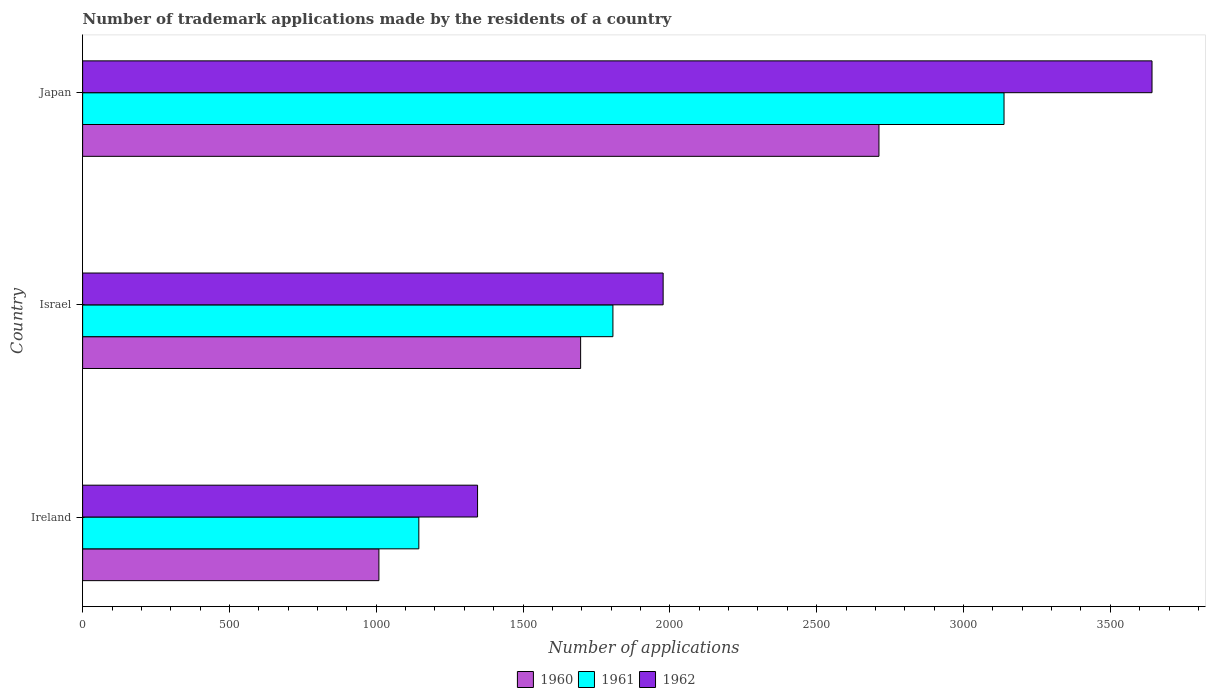How many groups of bars are there?
Offer a very short reply. 3. Are the number of bars on each tick of the Y-axis equal?
Make the answer very short. Yes. What is the label of the 1st group of bars from the top?
Provide a short and direct response. Japan. In how many cases, is the number of bars for a given country not equal to the number of legend labels?
Offer a terse response. 0. What is the number of trademark applications made by the residents in 1961 in Japan?
Make the answer very short. 3138. Across all countries, what is the maximum number of trademark applications made by the residents in 1962?
Offer a terse response. 3642. Across all countries, what is the minimum number of trademark applications made by the residents in 1962?
Give a very brief answer. 1345. In which country was the number of trademark applications made by the residents in 1960 maximum?
Your response must be concise. Japan. In which country was the number of trademark applications made by the residents in 1960 minimum?
Provide a short and direct response. Ireland. What is the total number of trademark applications made by the residents in 1960 in the graph?
Your answer should be very brief. 5417. What is the difference between the number of trademark applications made by the residents in 1960 in Israel and that in Japan?
Make the answer very short. -1016. What is the difference between the number of trademark applications made by the residents in 1961 in Japan and the number of trademark applications made by the residents in 1962 in Ireland?
Offer a very short reply. 1793. What is the average number of trademark applications made by the residents in 1960 per country?
Provide a short and direct response. 1805.67. What is the difference between the number of trademark applications made by the residents in 1962 and number of trademark applications made by the residents in 1961 in Israel?
Your answer should be compact. 171. What is the ratio of the number of trademark applications made by the residents in 1960 in Ireland to that in Israel?
Provide a succinct answer. 0.59. Is the number of trademark applications made by the residents in 1960 in Israel less than that in Japan?
Ensure brevity in your answer.  Yes. What is the difference between the highest and the second highest number of trademark applications made by the residents in 1961?
Your response must be concise. 1332. What is the difference between the highest and the lowest number of trademark applications made by the residents in 1962?
Your answer should be very brief. 2297. Is the sum of the number of trademark applications made by the residents in 1961 in Ireland and Israel greater than the maximum number of trademark applications made by the residents in 1960 across all countries?
Keep it short and to the point. Yes. What does the 2nd bar from the top in Israel represents?
Offer a terse response. 1961. What does the 1st bar from the bottom in Japan represents?
Your response must be concise. 1960. Is it the case that in every country, the sum of the number of trademark applications made by the residents in 1962 and number of trademark applications made by the residents in 1960 is greater than the number of trademark applications made by the residents in 1961?
Provide a short and direct response. Yes. How many bars are there?
Give a very brief answer. 9. How many countries are there in the graph?
Keep it short and to the point. 3. What is the difference between two consecutive major ticks on the X-axis?
Your answer should be compact. 500. Does the graph contain any zero values?
Keep it short and to the point. No. How many legend labels are there?
Your response must be concise. 3. What is the title of the graph?
Offer a terse response. Number of trademark applications made by the residents of a country. Does "1989" appear as one of the legend labels in the graph?
Ensure brevity in your answer.  No. What is the label or title of the X-axis?
Provide a succinct answer. Number of applications. What is the Number of applications of 1960 in Ireland?
Provide a succinct answer. 1009. What is the Number of applications of 1961 in Ireland?
Make the answer very short. 1145. What is the Number of applications in 1962 in Ireland?
Your answer should be compact. 1345. What is the Number of applications of 1960 in Israel?
Offer a terse response. 1696. What is the Number of applications in 1961 in Israel?
Keep it short and to the point. 1806. What is the Number of applications in 1962 in Israel?
Provide a short and direct response. 1977. What is the Number of applications in 1960 in Japan?
Your response must be concise. 2712. What is the Number of applications in 1961 in Japan?
Make the answer very short. 3138. What is the Number of applications of 1962 in Japan?
Make the answer very short. 3642. Across all countries, what is the maximum Number of applications of 1960?
Your answer should be very brief. 2712. Across all countries, what is the maximum Number of applications of 1961?
Offer a terse response. 3138. Across all countries, what is the maximum Number of applications in 1962?
Offer a terse response. 3642. Across all countries, what is the minimum Number of applications in 1960?
Keep it short and to the point. 1009. Across all countries, what is the minimum Number of applications of 1961?
Give a very brief answer. 1145. Across all countries, what is the minimum Number of applications in 1962?
Offer a very short reply. 1345. What is the total Number of applications in 1960 in the graph?
Offer a very short reply. 5417. What is the total Number of applications of 1961 in the graph?
Make the answer very short. 6089. What is the total Number of applications in 1962 in the graph?
Offer a terse response. 6964. What is the difference between the Number of applications of 1960 in Ireland and that in Israel?
Your response must be concise. -687. What is the difference between the Number of applications in 1961 in Ireland and that in Israel?
Your response must be concise. -661. What is the difference between the Number of applications of 1962 in Ireland and that in Israel?
Your answer should be very brief. -632. What is the difference between the Number of applications in 1960 in Ireland and that in Japan?
Offer a very short reply. -1703. What is the difference between the Number of applications in 1961 in Ireland and that in Japan?
Offer a terse response. -1993. What is the difference between the Number of applications of 1962 in Ireland and that in Japan?
Your answer should be compact. -2297. What is the difference between the Number of applications in 1960 in Israel and that in Japan?
Your answer should be very brief. -1016. What is the difference between the Number of applications of 1961 in Israel and that in Japan?
Offer a terse response. -1332. What is the difference between the Number of applications in 1962 in Israel and that in Japan?
Provide a succinct answer. -1665. What is the difference between the Number of applications of 1960 in Ireland and the Number of applications of 1961 in Israel?
Offer a very short reply. -797. What is the difference between the Number of applications in 1960 in Ireland and the Number of applications in 1962 in Israel?
Give a very brief answer. -968. What is the difference between the Number of applications of 1961 in Ireland and the Number of applications of 1962 in Israel?
Ensure brevity in your answer.  -832. What is the difference between the Number of applications in 1960 in Ireland and the Number of applications in 1961 in Japan?
Ensure brevity in your answer.  -2129. What is the difference between the Number of applications of 1960 in Ireland and the Number of applications of 1962 in Japan?
Offer a terse response. -2633. What is the difference between the Number of applications in 1961 in Ireland and the Number of applications in 1962 in Japan?
Provide a succinct answer. -2497. What is the difference between the Number of applications in 1960 in Israel and the Number of applications in 1961 in Japan?
Your answer should be very brief. -1442. What is the difference between the Number of applications in 1960 in Israel and the Number of applications in 1962 in Japan?
Provide a short and direct response. -1946. What is the difference between the Number of applications in 1961 in Israel and the Number of applications in 1962 in Japan?
Provide a succinct answer. -1836. What is the average Number of applications in 1960 per country?
Give a very brief answer. 1805.67. What is the average Number of applications in 1961 per country?
Your response must be concise. 2029.67. What is the average Number of applications of 1962 per country?
Make the answer very short. 2321.33. What is the difference between the Number of applications of 1960 and Number of applications of 1961 in Ireland?
Ensure brevity in your answer.  -136. What is the difference between the Number of applications in 1960 and Number of applications in 1962 in Ireland?
Offer a terse response. -336. What is the difference between the Number of applications in 1961 and Number of applications in 1962 in Ireland?
Your answer should be compact. -200. What is the difference between the Number of applications of 1960 and Number of applications of 1961 in Israel?
Provide a short and direct response. -110. What is the difference between the Number of applications in 1960 and Number of applications in 1962 in Israel?
Your answer should be compact. -281. What is the difference between the Number of applications of 1961 and Number of applications of 1962 in Israel?
Make the answer very short. -171. What is the difference between the Number of applications in 1960 and Number of applications in 1961 in Japan?
Provide a short and direct response. -426. What is the difference between the Number of applications in 1960 and Number of applications in 1962 in Japan?
Give a very brief answer. -930. What is the difference between the Number of applications in 1961 and Number of applications in 1962 in Japan?
Provide a succinct answer. -504. What is the ratio of the Number of applications of 1960 in Ireland to that in Israel?
Keep it short and to the point. 0.59. What is the ratio of the Number of applications of 1961 in Ireland to that in Israel?
Offer a very short reply. 0.63. What is the ratio of the Number of applications of 1962 in Ireland to that in Israel?
Make the answer very short. 0.68. What is the ratio of the Number of applications in 1960 in Ireland to that in Japan?
Provide a short and direct response. 0.37. What is the ratio of the Number of applications in 1961 in Ireland to that in Japan?
Provide a succinct answer. 0.36. What is the ratio of the Number of applications in 1962 in Ireland to that in Japan?
Your answer should be very brief. 0.37. What is the ratio of the Number of applications of 1960 in Israel to that in Japan?
Offer a very short reply. 0.63. What is the ratio of the Number of applications of 1961 in Israel to that in Japan?
Your answer should be very brief. 0.58. What is the ratio of the Number of applications in 1962 in Israel to that in Japan?
Provide a succinct answer. 0.54. What is the difference between the highest and the second highest Number of applications in 1960?
Make the answer very short. 1016. What is the difference between the highest and the second highest Number of applications of 1961?
Make the answer very short. 1332. What is the difference between the highest and the second highest Number of applications in 1962?
Provide a succinct answer. 1665. What is the difference between the highest and the lowest Number of applications in 1960?
Keep it short and to the point. 1703. What is the difference between the highest and the lowest Number of applications of 1961?
Your response must be concise. 1993. What is the difference between the highest and the lowest Number of applications of 1962?
Make the answer very short. 2297. 